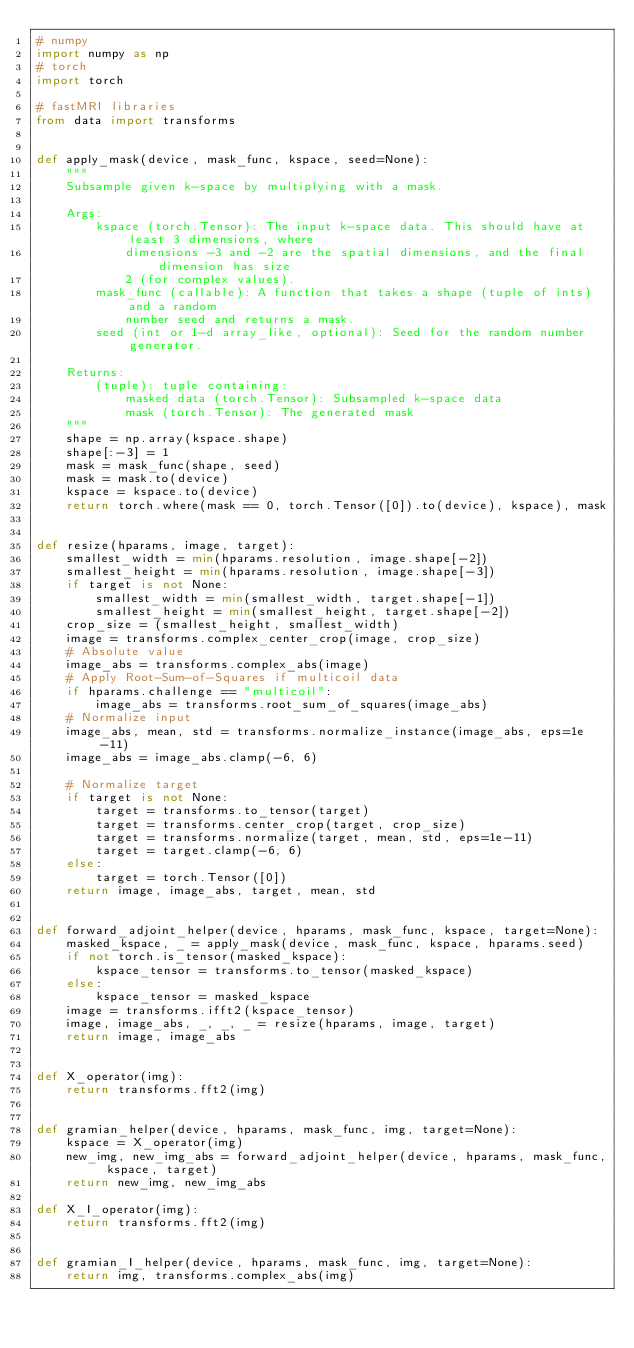<code> <loc_0><loc_0><loc_500><loc_500><_Python_># numpy
import numpy as np
# torch
import torch

# fastMRI libraries
from data import transforms


def apply_mask(device, mask_func, kspace, seed=None):
    """
    Subsample given k-space by multiplying with a mask.

    Args:
        kspace (torch.Tensor): The input k-space data. This should have at least 3 dimensions, where
            dimensions -3 and -2 are the spatial dimensions, and the final dimension has size
            2 (for complex values).
        mask_func (callable): A function that takes a shape (tuple of ints) and a random
            number seed and returns a mask.
        seed (int or 1-d array_like, optional): Seed for the random number generator.

    Returns:
        (tuple): tuple containing:
            masked data (torch.Tensor): Subsampled k-space data
            mask (torch.Tensor): The generated mask
    """
    shape = np.array(kspace.shape)
    shape[:-3] = 1
    mask = mask_func(shape, seed)
    mask = mask.to(device)
    kspace = kspace.to(device)
    return torch.where(mask == 0, torch.Tensor([0]).to(device), kspace), mask


def resize(hparams, image, target):
    smallest_width = min(hparams.resolution, image.shape[-2])
    smallest_height = min(hparams.resolution, image.shape[-3])
    if target is not None:
        smallest_width = min(smallest_width, target.shape[-1])
        smallest_height = min(smallest_height, target.shape[-2])
    crop_size = (smallest_height, smallest_width)
    image = transforms.complex_center_crop(image, crop_size)
    # Absolute value
    image_abs = transforms.complex_abs(image)
    # Apply Root-Sum-of-Squares if multicoil data
    if hparams.challenge == "multicoil":
        image_abs = transforms.root_sum_of_squares(image_abs)
    # Normalize input
    image_abs, mean, std = transforms.normalize_instance(image_abs, eps=1e-11)
    image_abs = image_abs.clamp(-6, 6)

    # Normalize target
    if target is not None:
        target = transforms.to_tensor(target)
        target = transforms.center_crop(target, crop_size)
        target = transforms.normalize(target, mean, std, eps=1e-11)
        target = target.clamp(-6, 6)
    else:
        target = torch.Tensor([0])
    return image, image_abs, target, mean, std


def forward_adjoint_helper(device, hparams, mask_func, kspace, target=None):
    masked_kspace, _ = apply_mask(device, mask_func, kspace, hparams.seed)
    if not torch.is_tensor(masked_kspace):
        kspace_tensor = transforms.to_tensor(masked_kspace)
    else:
        kspace_tensor = masked_kspace
    image = transforms.ifft2(kspace_tensor)
    image, image_abs, _, _, _ = resize(hparams, image, target)
    return image, image_abs


def X_operator(img):
    return transforms.fft2(img)


def gramian_helper(device, hparams, mask_func, img, target=None):
    kspace = X_operator(img)
    new_img, new_img_abs = forward_adjoint_helper(device, hparams, mask_func, kspace, target)
    return new_img, new_img_abs

def X_I_operator(img):
    return transforms.fft2(img)


def gramian_I_helper(device, hparams, mask_func, img, target=None):
    return img, transforms.complex_abs(img)
</code> 